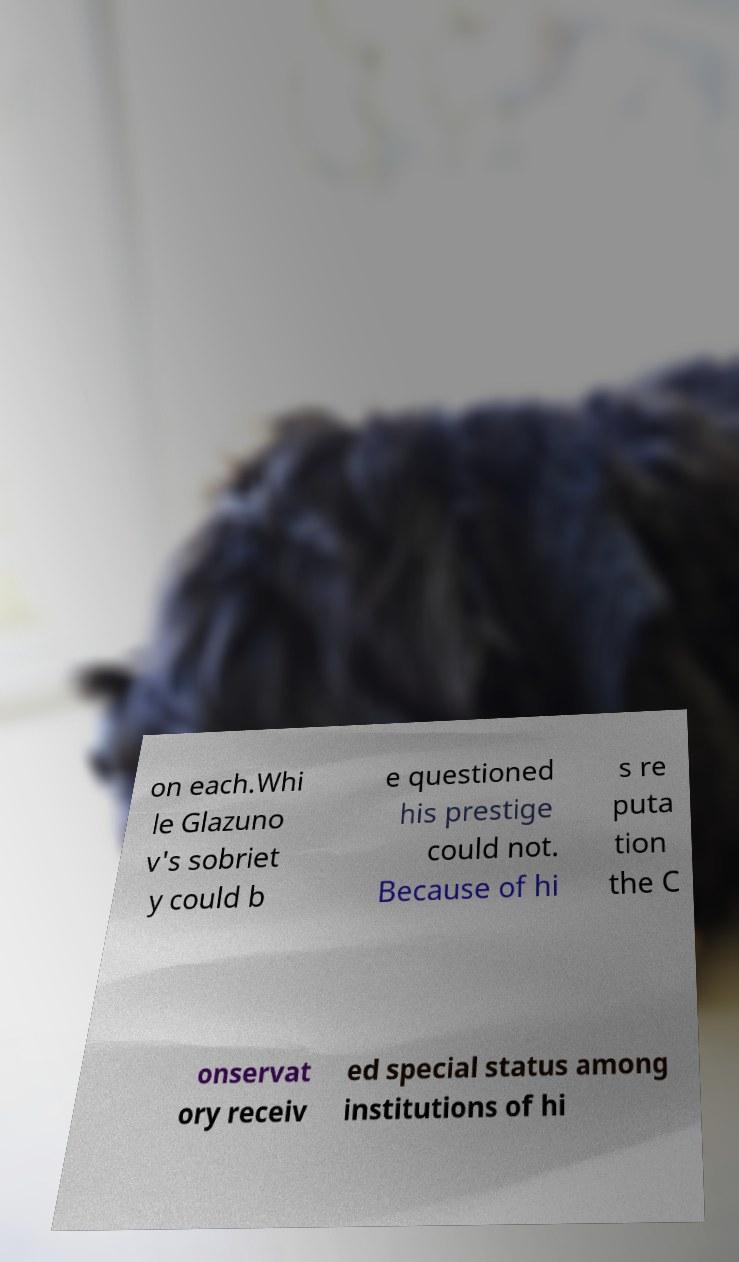What messages or text are displayed in this image? I need them in a readable, typed format. on each.Whi le Glazuno v's sobriet y could b e questioned his prestige could not. Because of hi s re puta tion the C onservat ory receiv ed special status among institutions of hi 